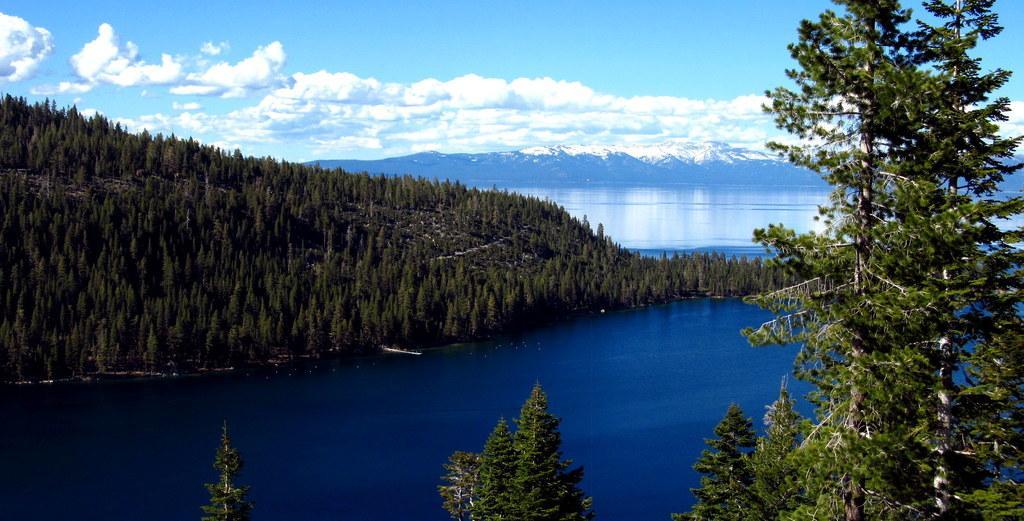Describe this image in one or two sentences. This image consists of many trees. At the bottom, there is water. In the background, we can see the mountains along with snow. At the top, there are clouds in the sky. 